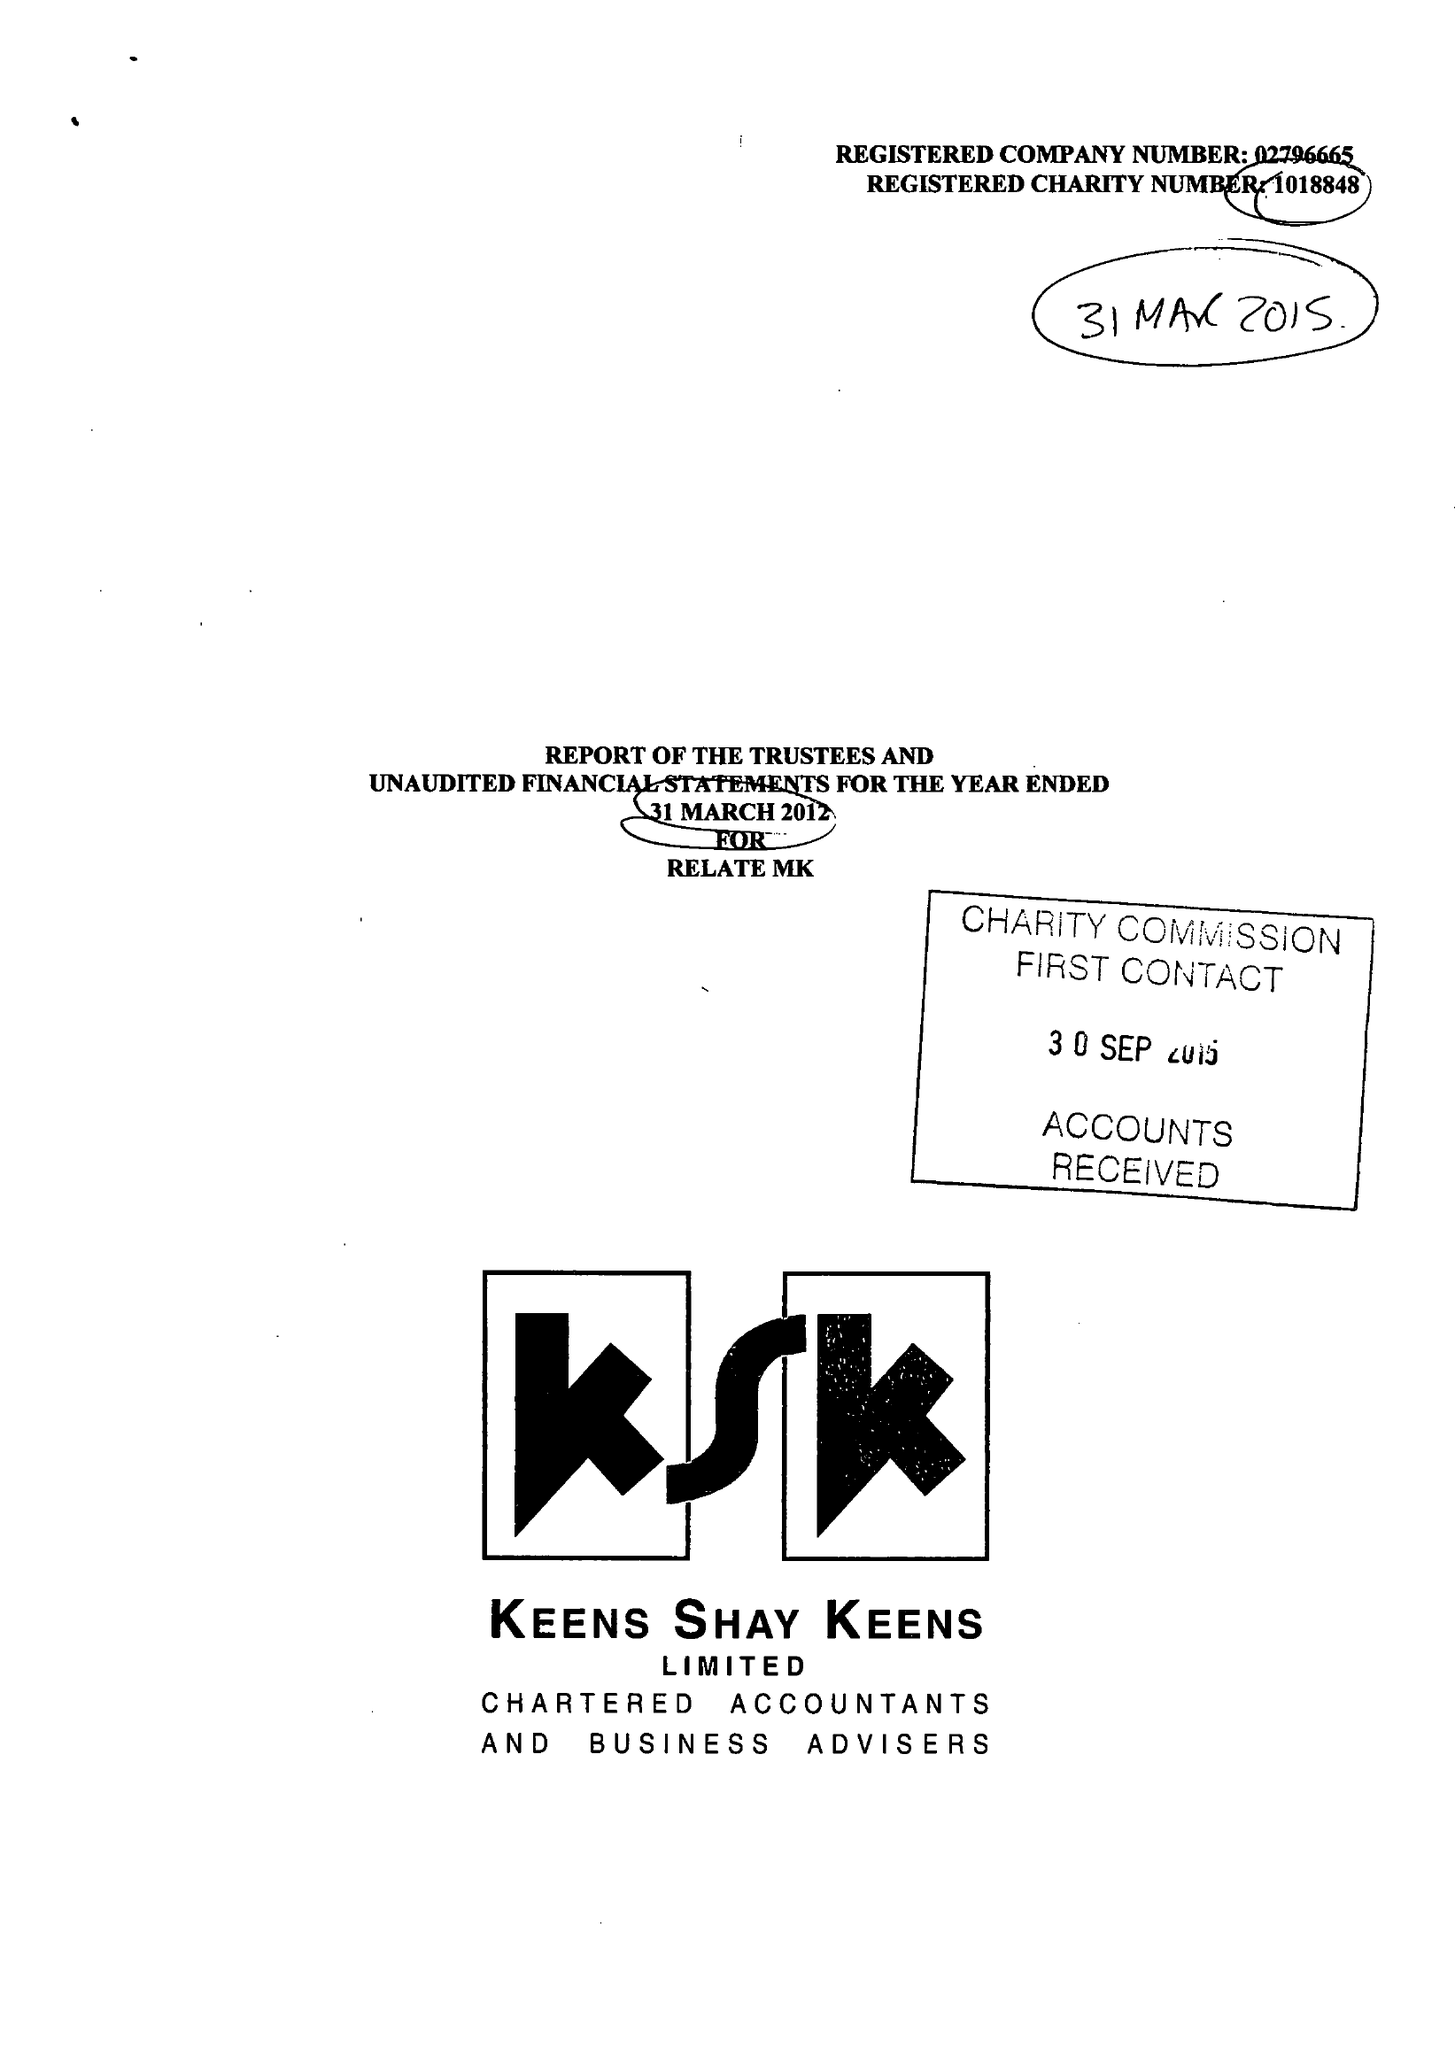What is the value for the spending_annually_in_british_pounds?
Answer the question using a single word or phrase. 205015.00 